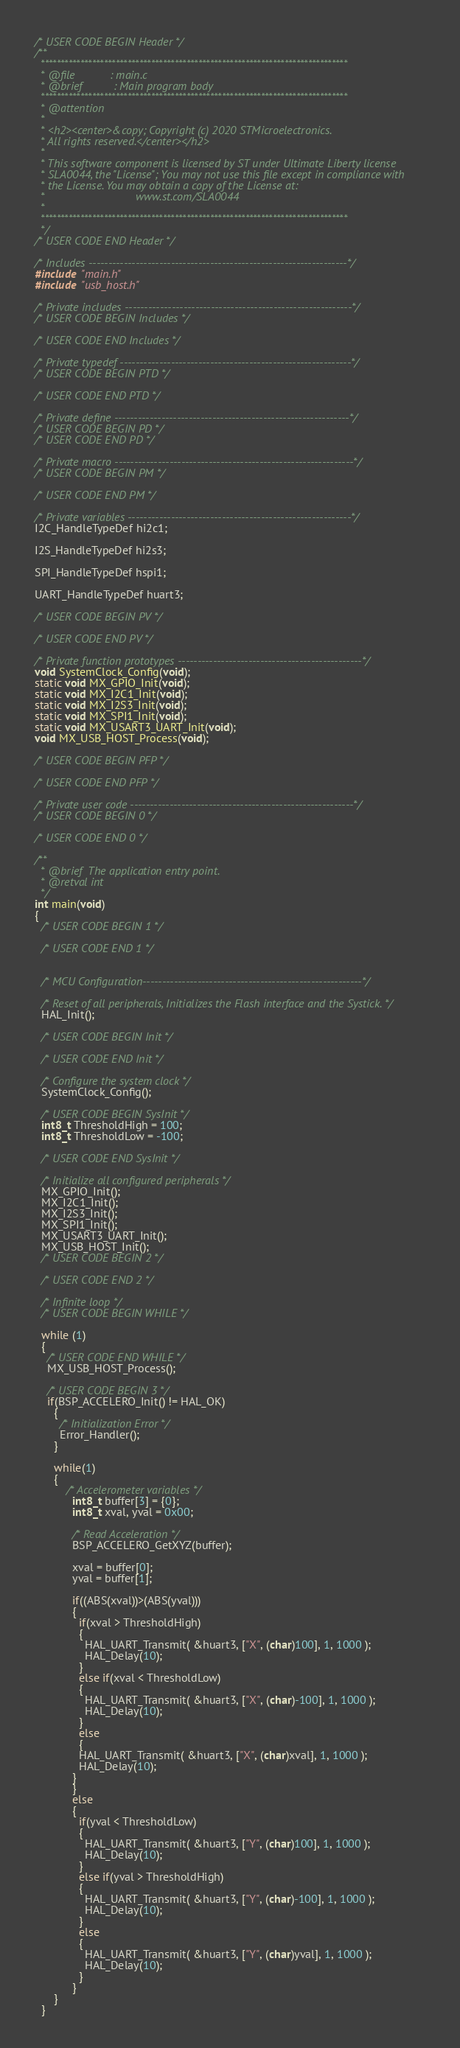Convert code to text. <code><loc_0><loc_0><loc_500><loc_500><_C_>/* USER CODE BEGIN Header */
/**
  ******************************************************************************
  * @file           : main.c
  * @brief          : Main program body
  ******************************************************************************
  * @attention
  *
  * <h2><center>&copy; Copyright (c) 2020 STMicroelectronics.
  * All rights reserved.</center></h2>
  *
  * This software component is licensed by ST under Ultimate Liberty license
  * SLA0044, the "License"; You may not use this file except in compliance with
  * the License. You may obtain a copy of the License at:
  *                             www.st.com/SLA0044
  *
  ******************************************************************************
  */
/* USER CODE END Header */

/* Includes ------------------------------------------------------------------*/
#include "main.h"
#include "usb_host.h"

/* Private includes ----------------------------------------------------------*/
/* USER CODE BEGIN Includes */

/* USER CODE END Includes */

/* Private typedef -----------------------------------------------------------*/
/* USER CODE BEGIN PTD */

/* USER CODE END PTD */

/* Private define ------------------------------------------------------------*/
/* USER CODE BEGIN PD */
/* USER CODE END PD */

/* Private macro -------------------------------------------------------------*/
/* USER CODE BEGIN PM */

/* USER CODE END PM */

/* Private variables ---------------------------------------------------------*/
I2C_HandleTypeDef hi2c1;

I2S_HandleTypeDef hi2s3;

SPI_HandleTypeDef hspi1;

UART_HandleTypeDef huart3;

/* USER CODE BEGIN PV */

/* USER CODE END PV */

/* Private function prototypes -----------------------------------------------*/
void SystemClock_Config(void);
static void MX_GPIO_Init(void);
static void MX_I2C1_Init(void);
static void MX_I2S3_Init(void);
static void MX_SPI1_Init(void);
static void MX_USART3_UART_Init(void);
void MX_USB_HOST_Process(void);

/* USER CODE BEGIN PFP */

/* USER CODE END PFP */

/* Private user code ---------------------------------------------------------*/
/* USER CODE BEGIN 0 */

/* USER CODE END 0 */

/**
  * @brief  The application entry point.
  * @retval int
  */
int main(void)
{
  /* USER CODE BEGIN 1 */

  /* USER CODE END 1 */
  

  /* MCU Configuration--------------------------------------------------------*/

  /* Reset of all peripherals, Initializes the Flash interface and the Systick. */
  HAL_Init();

  /* USER CODE BEGIN Init */

  /* USER CODE END Init */

  /* Configure the system clock */
  SystemClock_Config();

  /* USER CODE BEGIN SysInit */
  int8_t ThresholdHigh = 100;
  int8_t ThresholdLow = -100;

  /* USER CODE END SysInit */

  /* Initialize all configured peripherals */
  MX_GPIO_Init();
  MX_I2C1_Init();
  MX_I2S3_Init();
  MX_SPI1_Init();
  MX_USART3_UART_Init();
  MX_USB_HOST_Init();
  /* USER CODE BEGIN 2 */

  /* USER CODE END 2 */

  /* Infinite loop */
  /* USER CODE BEGIN WHILE */

  while (1)
  {
    /* USER CODE END WHILE */
    MX_USB_HOST_Process();

    /* USER CODE BEGIN 3 */
    if(BSP_ACCELERO_Init() != HAL_OK)
      {
        /* Initialization Error */
        Error_Handler();
      }

      while(1)
      {
    	  /* Accelerometer variables */
    	  	int8_t buffer[3] = {0};
    	    int8_t xval, yval = 0x00;

    	    /* Read Acceleration */
    	    BSP_ACCELERO_GetXYZ(buffer);

    	    xval = buffer[0];
    	    yval = buffer[1];

    	    if((ABS(xval))>(ABS(yval)))
    	    {
    	      if(xval > ThresholdHigh)
    	      {
    	        HAL_UART_Transmit( &huart3, ["X", (char)100], 1, 1000 );
    	        HAL_Delay(10);
    	      }
    	      else if(xval < ThresholdLow)
    	      {
    	        HAL_UART_Transmit( &huart3, ["X", (char)-100], 1, 1000 );
    	        HAL_Delay(10);
    	      }
    	      else
    	      {
              HAL_UART_Transmit( &huart3, ["X", (char)xval], 1, 1000 );
              HAL_Delay(10);
            }
    	    }
    	    else
    	    {
    	      if(yval < ThresholdLow)
    	      {
    	        HAL_UART_Transmit( &huart3, ["Y", (char)100], 1, 1000 );
    	        HAL_Delay(10);
    	      }
    	      else if(yval > ThresholdHigh)
    	      {
    	        HAL_UART_Transmit( &huart3, ["Y", (char)-100], 1, 1000 );
    	        HAL_Delay(10);
    	      }
    	      else
    	      {
      	        HAL_UART_Transmit( &huart3, ["Y", (char)yval], 1, 1000 );
      	        HAL_Delay(10);
    	      }
    	    }
      }
  }</code> 